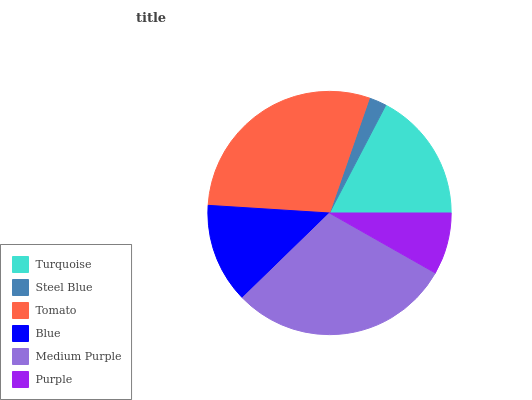Is Steel Blue the minimum?
Answer yes or no. Yes. Is Medium Purple the maximum?
Answer yes or no. Yes. Is Tomato the minimum?
Answer yes or no. No. Is Tomato the maximum?
Answer yes or no. No. Is Tomato greater than Steel Blue?
Answer yes or no. Yes. Is Steel Blue less than Tomato?
Answer yes or no. Yes. Is Steel Blue greater than Tomato?
Answer yes or no. No. Is Tomato less than Steel Blue?
Answer yes or no. No. Is Turquoise the high median?
Answer yes or no. Yes. Is Blue the low median?
Answer yes or no. Yes. Is Blue the high median?
Answer yes or no. No. Is Turquoise the low median?
Answer yes or no. No. 